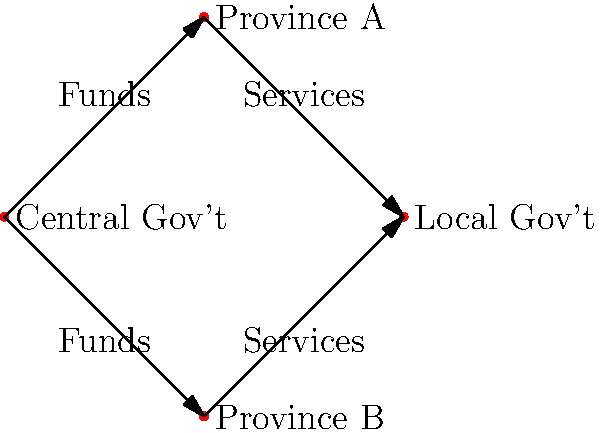In a decentralized government system, how does the flow of resources typically occur between central and local governments, and what potential challenges might arise in ensuring equitable distribution, particularly in regions with varying levels of development? 1. Resource flow in a decentralized system:
   a. Central government allocates funds to provinces/states.
   b. Provinces/states distribute resources to local governments.
   c. Local governments provide services to citizens.

2. Typical resource flow pattern:
   a. Funds flow from central to provincial/state governments.
   b. Provincial/state governments allocate funds to local governments.
   c. Local governments use funds to provide services to citizens.

3. Challenges in equitable distribution:
   a. Varying levels of development between regions.
   b. Differences in resource generation capabilities.
   c. Political influence and favoritism.

4. Potential solutions:
   a. Implement needs-based funding formulas.
   b. Establish transparent allocation mechanisms.
   c. Encourage local revenue generation.

5. Importance of balance:
   a. Ensure national priorities are met.
   b. Allow for local autonomy and decision-making.
   c. Address specific regional needs and challenges.

6. Monitoring and accountability:
   a. Regular audits of fund allocation and usage.
   b. Performance metrics for service delivery.
   c. Citizen feedback mechanisms.

7. Capacity building:
   a. Train local officials in resource management.
   b. Develop local expertise in service delivery.
   c. Foster innovation in governance at the local level.
Answer: Funds flow from central to provincial governments, then to local governments for service delivery, with challenges in ensuring equitable distribution due to regional disparities. 